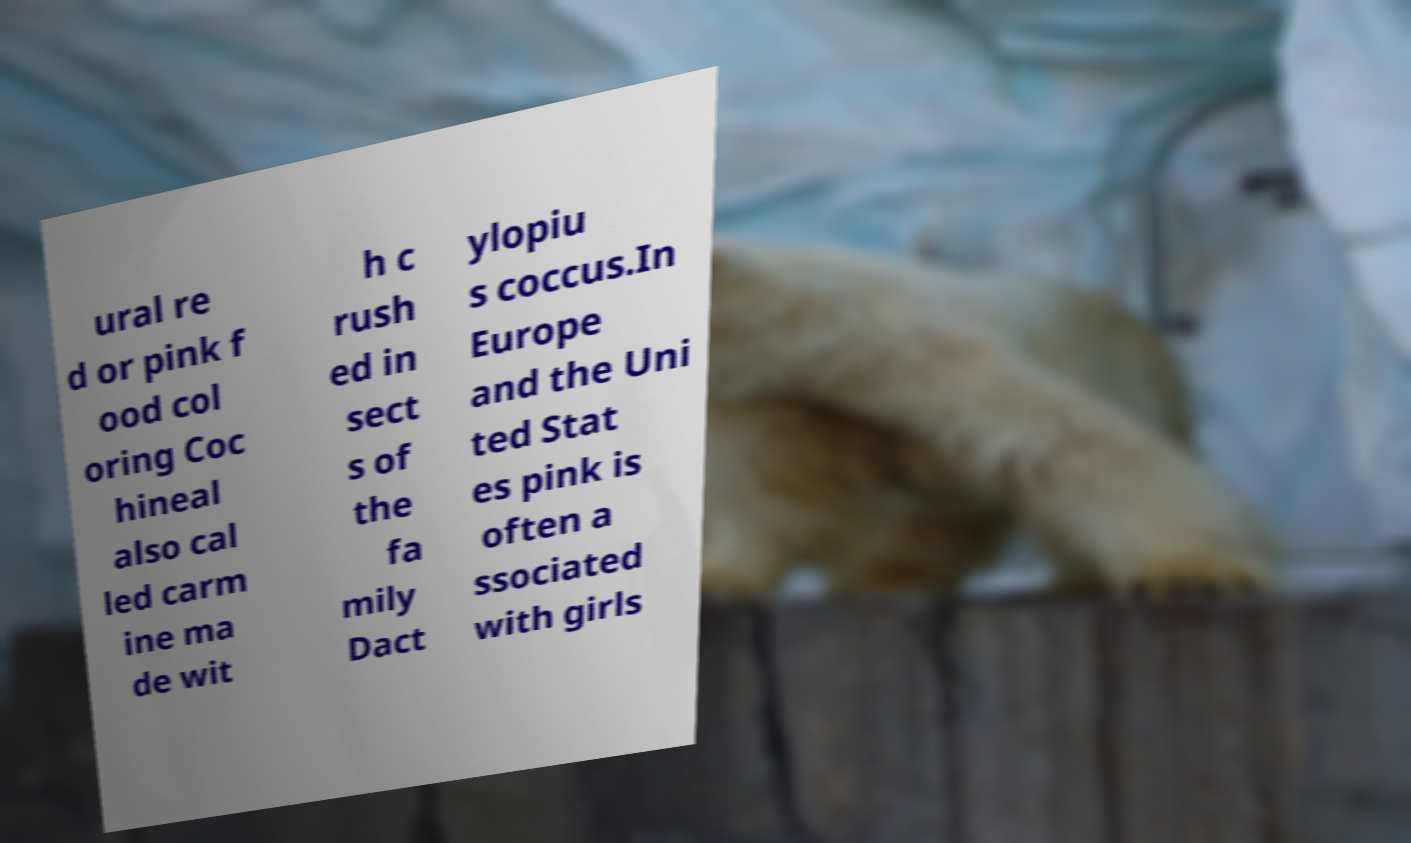Could you assist in decoding the text presented in this image and type it out clearly? ural re d or pink f ood col oring Coc hineal also cal led carm ine ma de wit h c rush ed in sect s of the fa mily Dact ylopiu s coccus.In Europe and the Uni ted Stat es pink is often a ssociated with girls 